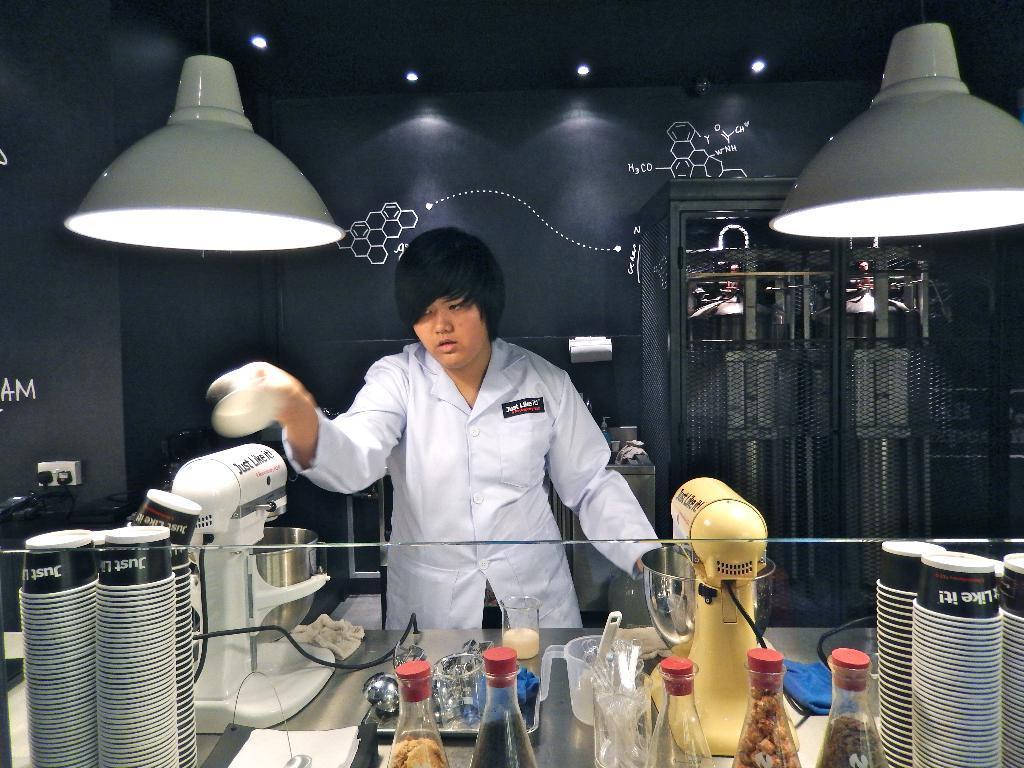Please provide a concise description of this image. In this image I can see the person is holding something. I can see few bottles, cups, spoons, mixers and few objects on the table. In the background I can see few cylinders, few objects and the black and white color wall. 